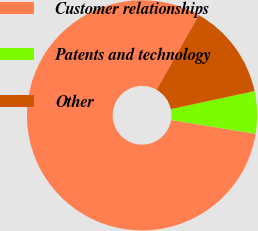Convert chart. <chart><loc_0><loc_0><loc_500><loc_500><pie_chart><fcel>Customer relationships<fcel>Patents and technology<fcel>Other<nl><fcel>80.64%<fcel>5.94%<fcel>13.41%<nl></chart> 